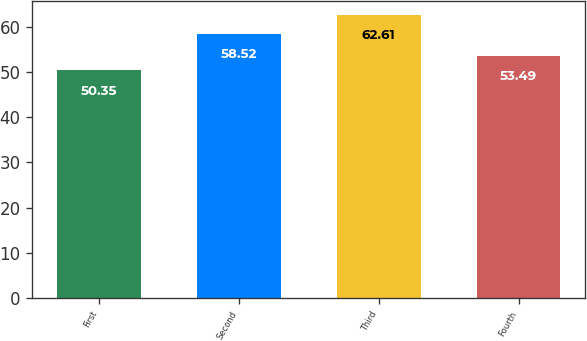Convert chart. <chart><loc_0><loc_0><loc_500><loc_500><bar_chart><fcel>First<fcel>Second<fcel>Third<fcel>Fourth<nl><fcel>50.35<fcel>58.52<fcel>62.61<fcel>53.49<nl></chart> 